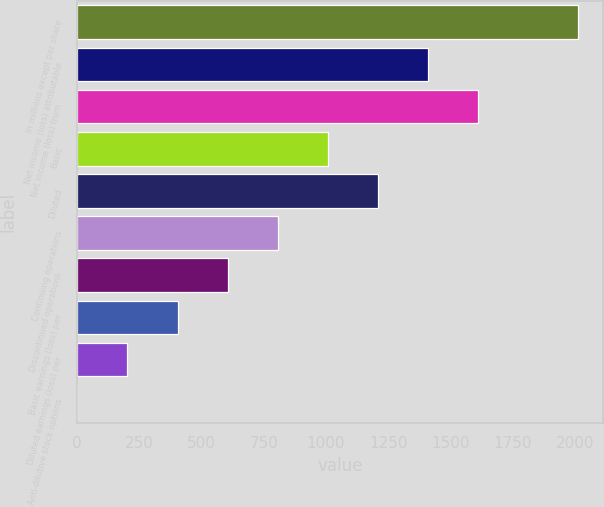Convert chart. <chart><loc_0><loc_0><loc_500><loc_500><bar_chart><fcel>In millions except per share<fcel>Net income (loss) attributable<fcel>Net income (loss) from<fcel>Basic<fcel>Diluted<fcel>Continuing operations<fcel>Discontinued operations<fcel>Basic earnings (loss) per<fcel>Diluted earnings (loss) per<fcel>Anti-dilutive stock options<nl><fcel>2014<fcel>1409.95<fcel>1611.3<fcel>1007.25<fcel>1208.6<fcel>805.9<fcel>604.55<fcel>403.2<fcel>201.85<fcel>0.5<nl></chart> 